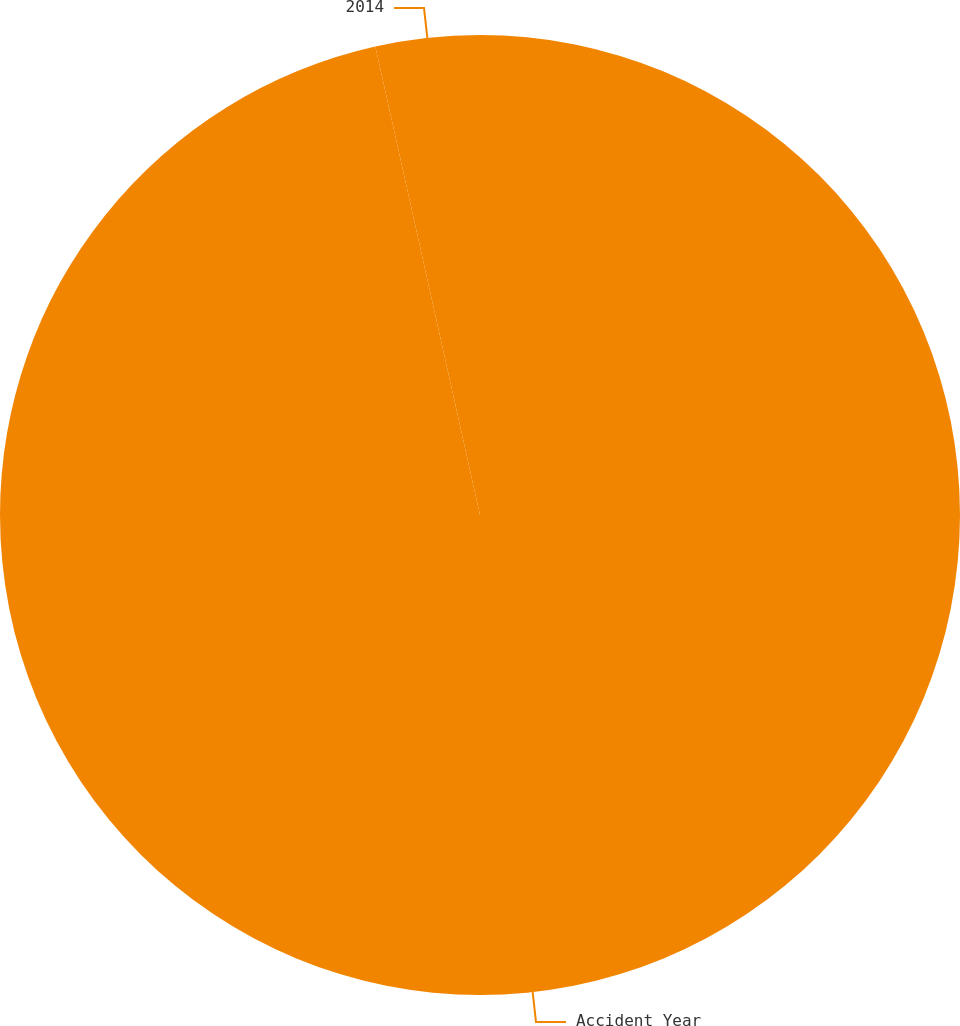Convert chart to OTSL. <chart><loc_0><loc_0><loc_500><loc_500><pie_chart><fcel>Accident Year<fcel>2014<nl><fcel>96.5%<fcel>3.5%<nl></chart> 